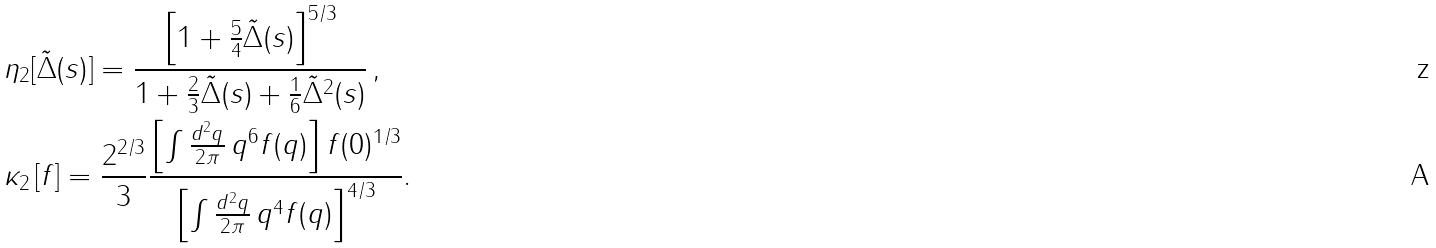<formula> <loc_0><loc_0><loc_500><loc_500>& \eta _ { 2 } [ \tilde { \Delta } ( s ) ] = \frac { \left [ 1 + \frac { 5 } { 4 } \tilde { \Delta } ( s ) \right ] ^ { 5 / 3 } } { 1 + \frac { 2 } { 3 } \tilde { \Delta } ( s ) + \frac { 1 } { 6 } \tilde { \Delta } ^ { 2 } ( s ) } \, , \\ & \kappa _ { 2 } \left [ f \right ] = \frac { 2 ^ { 2 / 3 } } { 3 } \frac { \left [ \int \frac { d ^ { 2 } q } { 2 \pi } \, q ^ { 6 } f ( q ) \right ] f ( 0 ) ^ { 1 / 3 } } { \left [ \int \frac { d ^ { 2 } q } { 2 \pi } \, q ^ { 4 } f ( q ) \right ] ^ { 4 / 3 } } .</formula> 